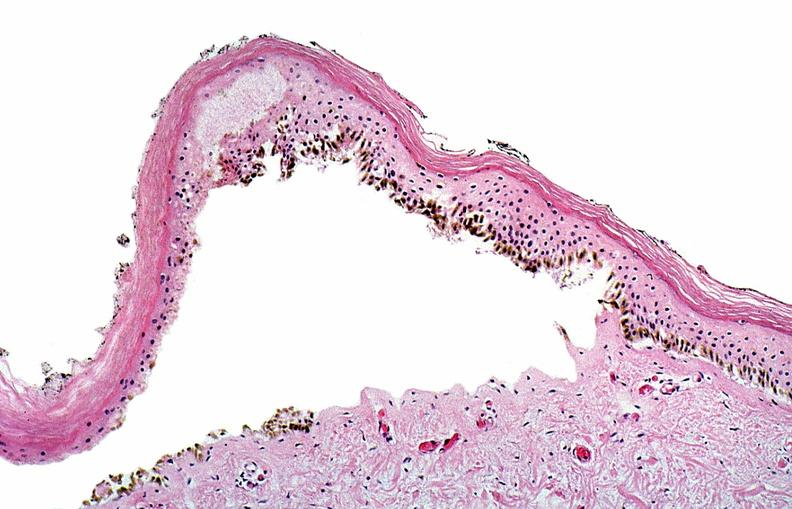does this image show thermal burned skin?
Answer the question using a single word or phrase. Yes 